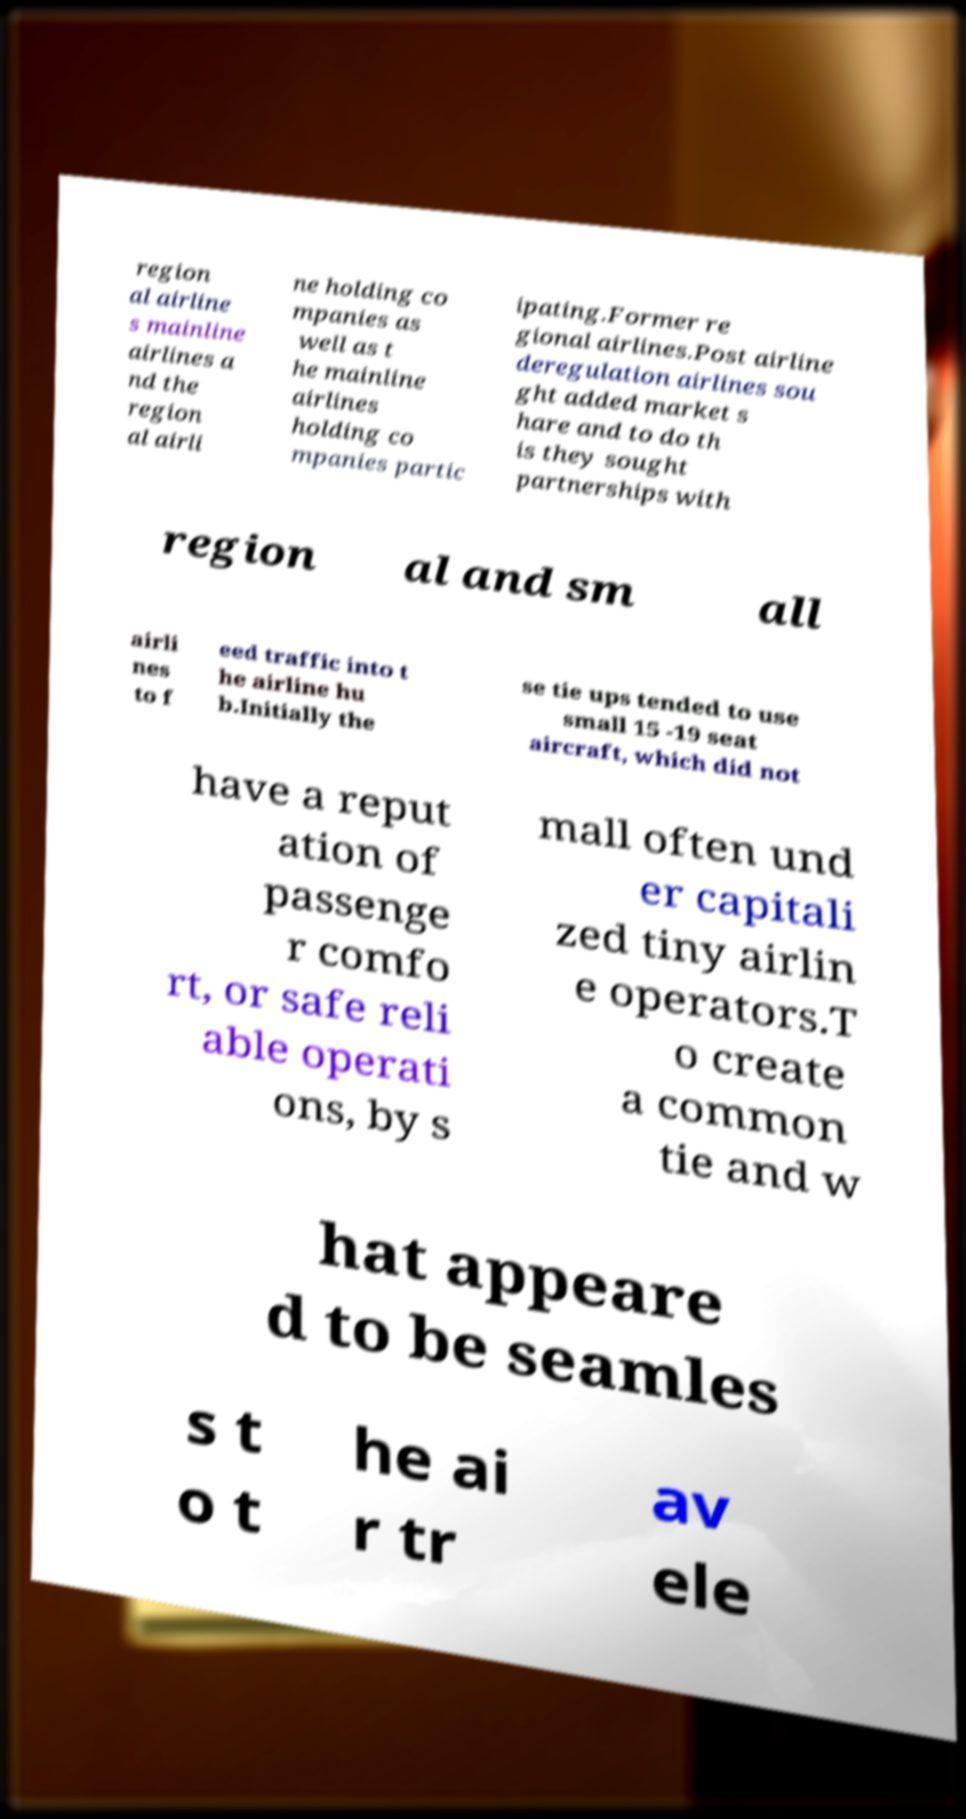For documentation purposes, I need the text within this image transcribed. Could you provide that? region al airline s mainline airlines a nd the region al airli ne holding co mpanies as well as t he mainline airlines holding co mpanies partic ipating.Former re gional airlines.Post airline deregulation airlines sou ght added market s hare and to do th is they sought partnerships with region al and sm all airli nes to f eed traffic into t he airline hu b.Initially the se tie ups tended to use small 15 -19 seat aircraft, which did not have a reput ation of passenge r comfo rt, or safe reli able operati ons, by s mall often und er capitali zed tiny airlin e operators.T o create a common tie and w hat appeare d to be seamles s t o t he ai r tr av ele 